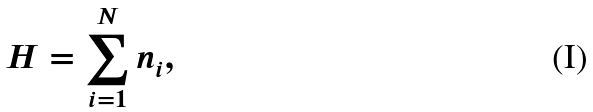<formula> <loc_0><loc_0><loc_500><loc_500>H = \sum _ { i = 1 } ^ { N } n _ { i } ,</formula> 